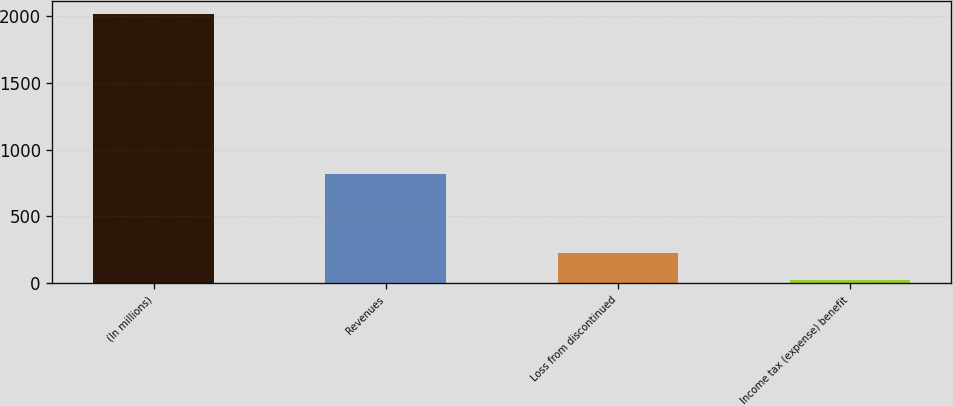Convert chart. <chart><loc_0><loc_0><loc_500><loc_500><bar_chart><fcel>(In millions)<fcel>Revenues<fcel>Loss from discontinued<fcel>Income tax (expense) benefit<nl><fcel>2014<fcel>821.2<fcel>224.8<fcel>26<nl></chart> 